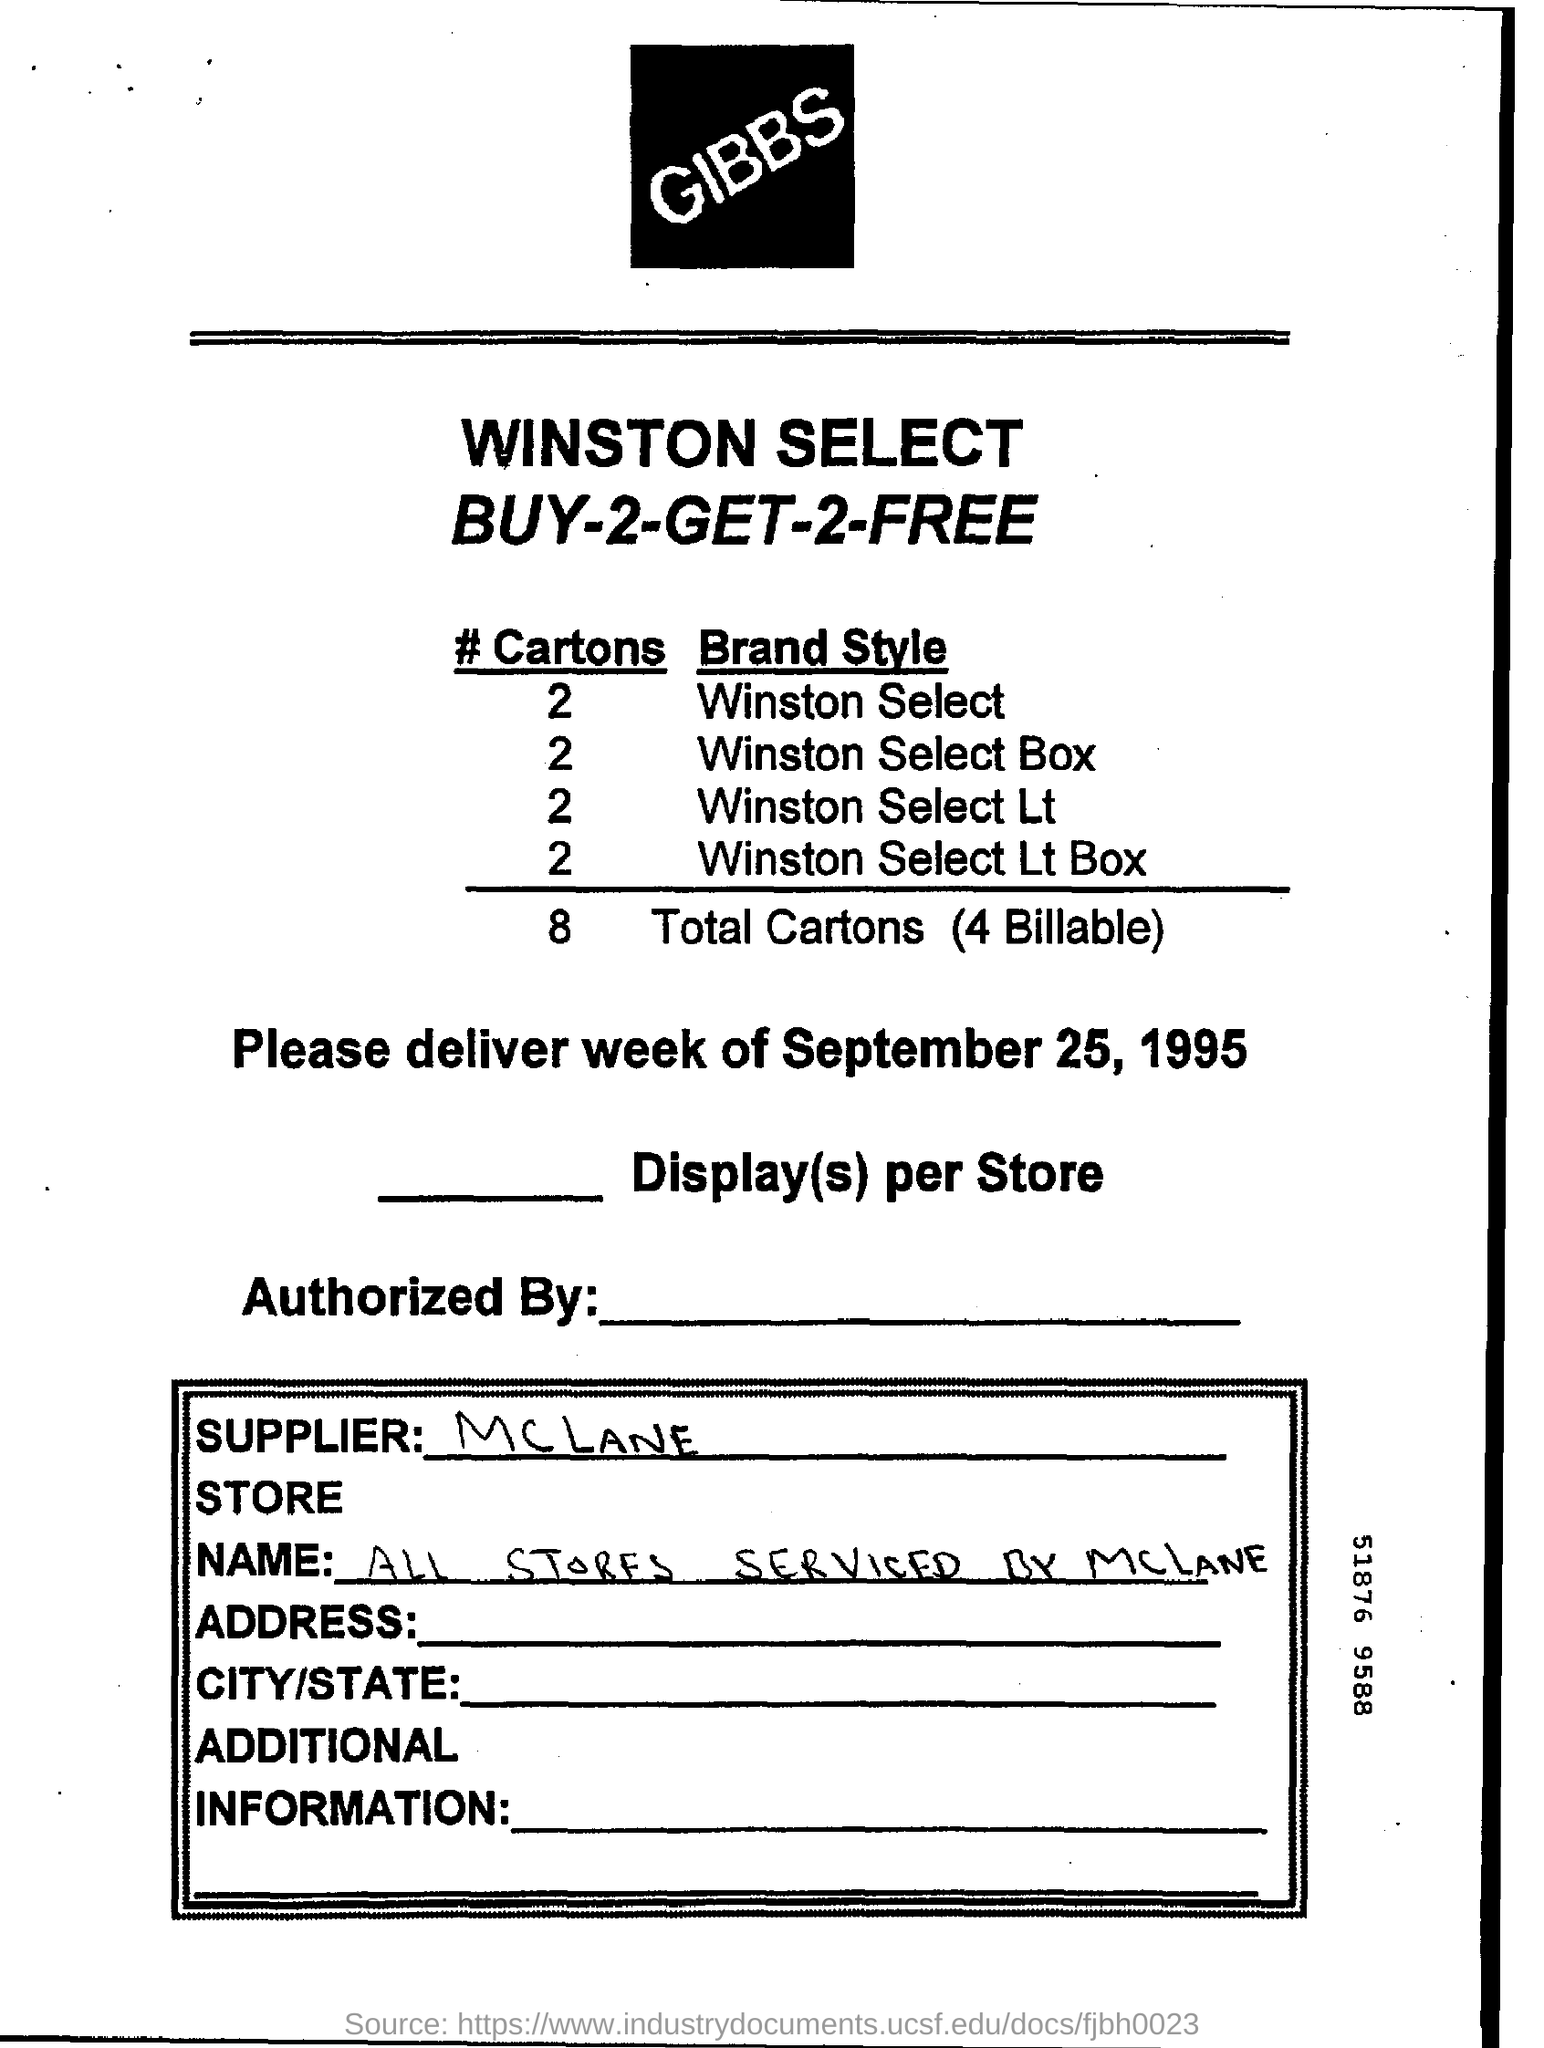Who is the supplier ?
Keep it short and to the point. McLane. How many cartons are billable ?
Offer a terse response. 4 Billable. What is the total number of cartons ?
Offer a very short reply. 8. What is the store name ?
Offer a terse response. All stores serviced by McLane. Mention the date of delivery week.
Ensure brevity in your answer.  September 25, 1995. 